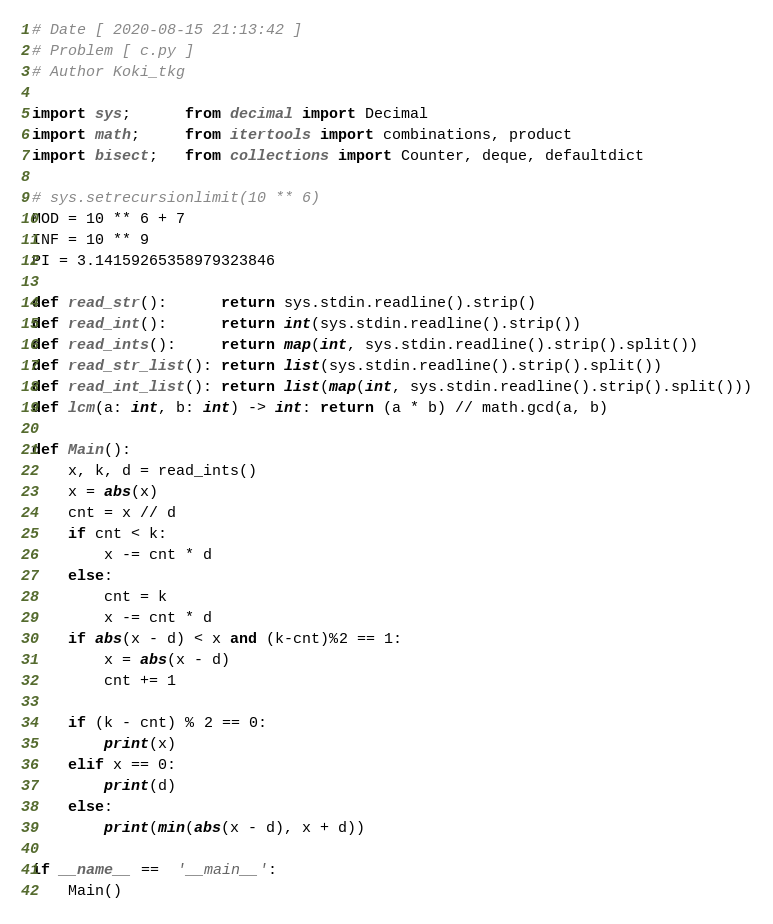Convert code to text. <code><loc_0><loc_0><loc_500><loc_500><_Python_># Date [ 2020-08-15 21:13:42 ]
# Problem [ c.py ]
# Author Koki_tkg

import sys;      from decimal import Decimal
import math;     from itertools import combinations, product
import bisect;   from collections import Counter, deque, defaultdict

# sys.setrecursionlimit(10 ** 6)
MOD = 10 ** 6 + 7
INF = 10 ** 9
PI = 3.14159265358979323846

def read_str():      return sys.stdin.readline().strip()
def read_int():      return int(sys.stdin.readline().strip())
def read_ints():     return map(int, sys.stdin.readline().strip().split())
def read_str_list(): return list(sys.stdin.readline().strip().split())
def read_int_list(): return list(map(int, sys.stdin.readline().strip().split()))
def lcm(a: int, b: int) -> int: return (a * b) // math.gcd(a, b)

def Main():
    x, k, d = read_ints()
    x = abs(x)
    cnt = x // d
    if cnt < k:
        x -= cnt * d
    else:
        cnt = k
        x -= cnt * d
    if abs(x - d) < x and (k-cnt)%2 == 1:
        x = abs(x - d)
        cnt += 1
    
    if (k - cnt) % 2 == 0:
        print(x)
    elif x == 0:
        print(d)
    else:
        print(min(abs(x - d), x + d)) 

if __name__ ==  '__main__':
    Main()</code> 